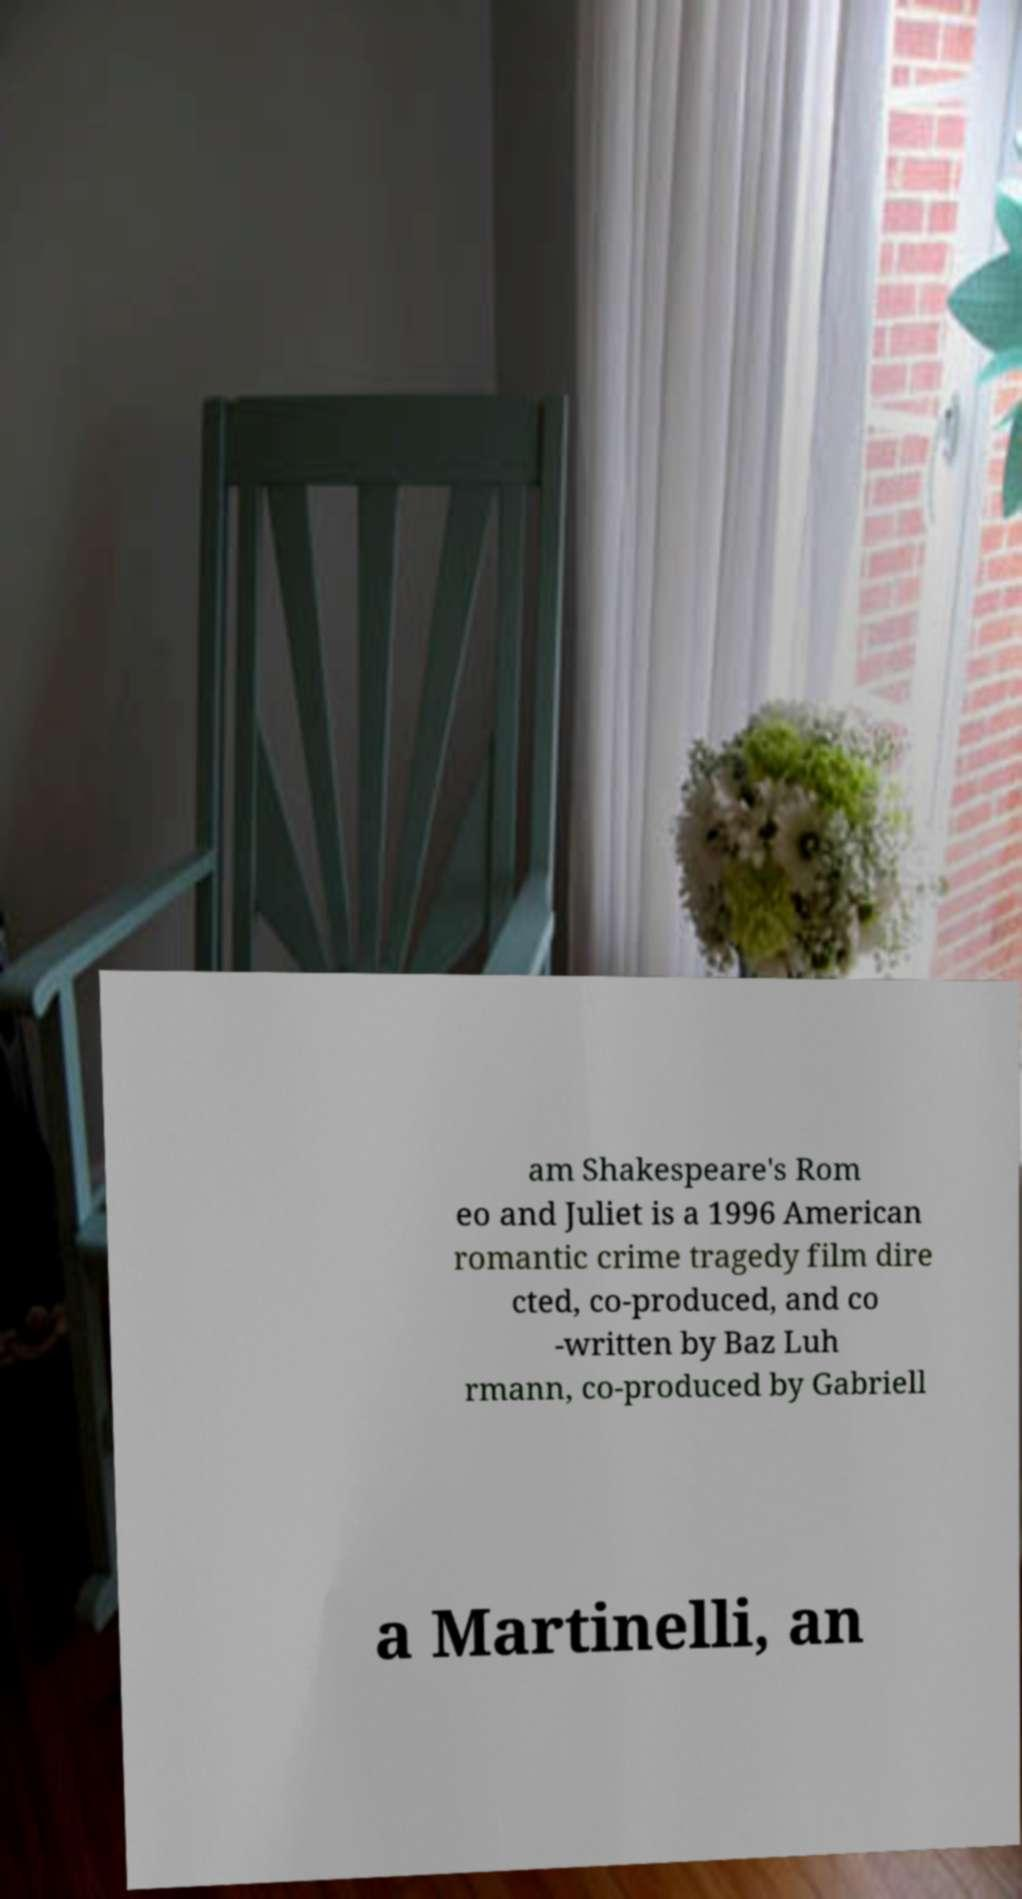There's text embedded in this image that I need extracted. Can you transcribe it verbatim? am Shakespeare's Rom eo and Juliet is a 1996 American romantic crime tragedy film dire cted, co-produced, and co -written by Baz Luh rmann, co-produced by Gabriell a Martinelli, an 